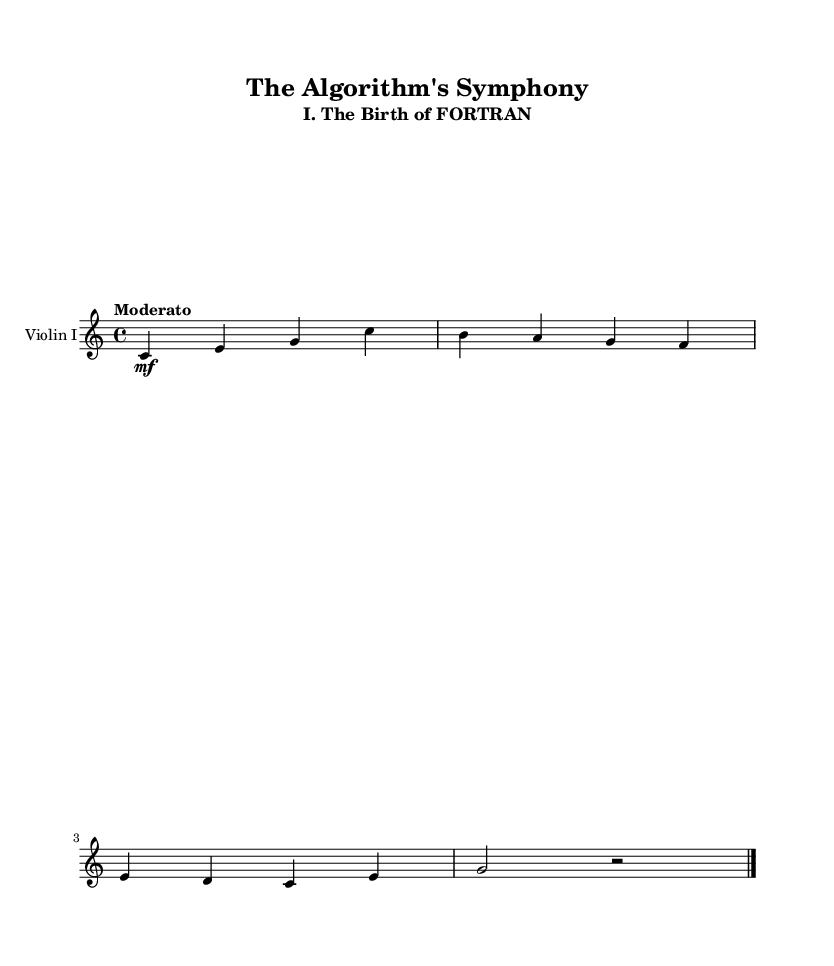What is the key signature of this music? The key signature is found at the beginning of the score and indicates that the piece is in C major, which has no sharps or flats.
Answer: C major What is the time signature of this music? The time signature is indicated at the beginning, showing a fraction format. It represents that there are four beats in each measure and the quarter note receives one beat.
Answer: Four-four What is the tempo marking given for this piece? The tempo is specified in a textual format at the beginning of the score. It indicates that the piece should be played at a moderate speed.
Answer: Moderato How many measures are in this score? To find the number of measures, we count each grouping of notes and rests that are enclosed between bar lines. In this score, there are four measures shown.
Answer: Four What is the primary instrument featured in this composition? The instrument is directly stated in the staff header at the beginning of the score, indicating what instrument plays the written music.
Answer: Violin I What is the title of this movement in the symphony? The title is mentioned at the top of the score, clarifying which part of the symphony it belongs to.
Answer: The Birth of FORTRAN What is the last note played in this fragment? The last note can be determined by looking at the last note written before the final bar line, which concludes the musical excerpt. The last note is a rest, indicated by a rest symbol.
Answer: Rest 